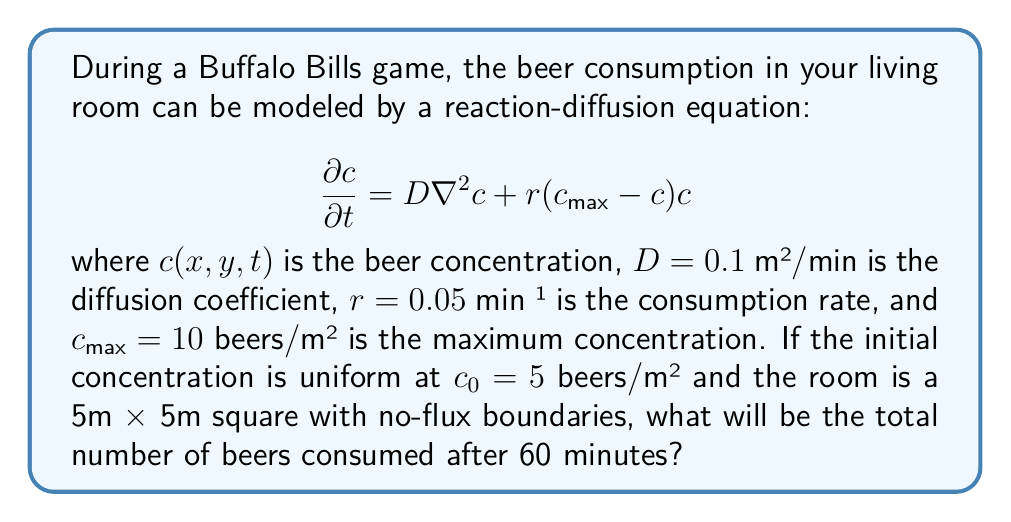Can you answer this question? To solve this problem, we need to follow these steps:

1) First, we recognize that the equation is a Fisher-KPP equation, which models population growth with diffusion. In our case, it models beer consumption spreading through the room.

2) The reaction term $r(c_{max} - c)c$ represents the consumption rate, which is highest when $c$ is at half of $c_{max}$.

3) Given the uniform initial condition and no-flux boundaries, we can assume that the concentration will remain uniform throughout the room. This simplifies our problem to an ordinary differential equation:

   $$\frac{dc}{dt} = r(c_{max} - c)c$$

4) This ODE can be solved analytically:

   $$c(t) = \frac{c_{max}c_0}{c_0 + (c_{max} - c_0)e^{-rc_{max}t}}$$

5) Substituting our values:

   $$c(t) = \frac{10 \cdot 5}{5 + (10 - 5)e^{-0.05 \cdot 10 \cdot t}}$$

6) At t = 60 minutes:

   $$c(60) = \frac{50}{5 + 5e^{-30}} \approx 9.93$$ beers/m²

7) The amount consumed is the difference between the initial and final concentrations:

   $$\text{Consumed} = c(60) - c_0 = 9.93 - 5 = 4.93$$ beers/m²

8) To get the total number of beers, we multiply by the area of the room:

   $$\text{Total consumed} = 4.93 \cdot 5 \cdot 5 = 123.25$$ beers

Therefore, after 60 minutes, approximately 123 beers will have been consumed.
Answer: 123 beers 